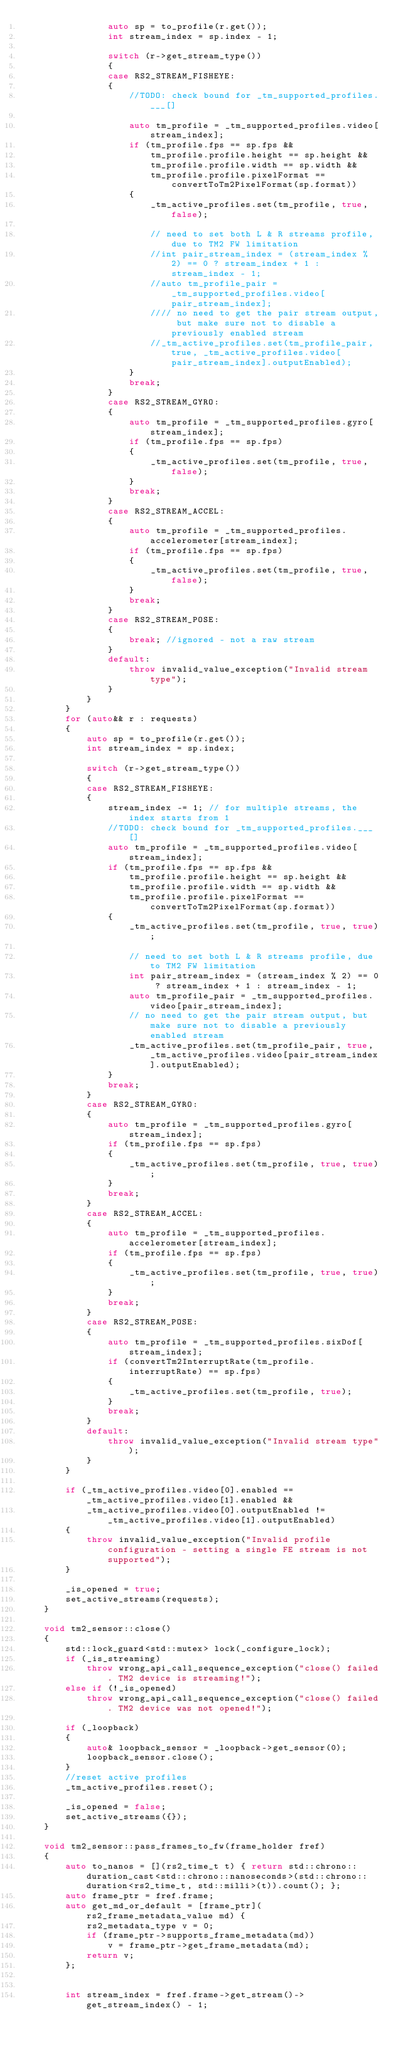<code> <loc_0><loc_0><loc_500><loc_500><_C++_>                auto sp = to_profile(r.get());
                int stream_index = sp.index - 1;

                switch (r->get_stream_type())
                {
                case RS2_STREAM_FISHEYE:
                {
                    //TODO: check bound for _tm_supported_profiles.___[]

                    auto tm_profile = _tm_supported_profiles.video[stream_index];
                    if (tm_profile.fps == sp.fps &&
                        tm_profile.profile.height == sp.height &&
                        tm_profile.profile.width == sp.width &&
                        tm_profile.profile.pixelFormat == convertToTm2PixelFormat(sp.format))
                    {
                        _tm_active_profiles.set(tm_profile, true, false);

                        // need to set both L & R streams profile, due to TM2 FW limitation
                        //int pair_stream_index = (stream_index % 2) == 0 ? stream_index + 1 : stream_index - 1;
                        //auto tm_profile_pair = _tm_supported_profiles.video[pair_stream_index];
                        //// no need to get the pair stream output, but make sure not to disable a previously enabled stream
                        //_tm_active_profiles.set(tm_profile_pair, true, _tm_active_profiles.video[pair_stream_index].outputEnabled);
                    }
                    break;
                }
                case RS2_STREAM_GYRO:
                {
                    auto tm_profile = _tm_supported_profiles.gyro[stream_index];
                    if (tm_profile.fps == sp.fps)
                    {
                        _tm_active_profiles.set(tm_profile, true, false);
                    }
                    break;
                }
                case RS2_STREAM_ACCEL:
                {
                    auto tm_profile = _tm_supported_profiles.accelerometer[stream_index];
                    if (tm_profile.fps == sp.fps)
                    {
                        _tm_active_profiles.set(tm_profile, true, false);
                    }
                    break;
                }
                case RS2_STREAM_POSE:
                {
                    break; //ignored - not a raw stream
                }
                default:
                    throw invalid_value_exception("Invalid stream type");
                }
            }
        }
        for (auto&& r : requests)
        {
            auto sp = to_profile(r.get());
            int stream_index = sp.index;
            
            switch (r->get_stream_type())
            {
            case RS2_STREAM_FISHEYE:
            {
                stream_index -= 1; // for multiple streams, the index starts from 1
                //TODO: check bound for _tm_supported_profiles.___[]
                auto tm_profile = _tm_supported_profiles.video[stream_index];
                if (tm_profile.fps == sp.fps &&
                    tm_profile.profile.height == sp.height &&
                    tm_profile.profile.width == sp.width &&
                    tm_profile.profile.pixelFormat == convertToTm2PixelFormat(sp.format))
                {
                    _tm_active_profiles.set(tm_profile, true, true);

                    // need to set both L & R streams profile, due to TM2 FW limitation
                    int pair_stream_index = (stream_index % 2) == 0 ? stream_index + 1 : stream_index - 1;
                    auto tm_profile_pair = _tm_supported_profiles.video[pair_stream_index];
                    // no need to get the pair stream output, but make sure not to disable a previously enabled stream
                    _tm_active_profiles.set(tm_profile_pair, true, _tm_active_profiles.video[pair_stream_index].outputEnabled);
                }
                break;
            }
            case RS2_STREAM_GYRO:
            {
                auto tm_profile = _tm_supported_profiles.gyro[stream_index];
                if (tm_profile.fps == sp.fps)
                {
                    _tm_active_profiles.set(tm_profile, true, true);
                }
                break;
            }
            case RS2_STREAM_ACCEL:
            {
                auto tm_profile = _tm_supported_profiles.accelerometer[stream_index];
                if (tm_profile.fps == sp.fps)
                {
                    _tm_active_profiles.set(tm_profile, true, true);
                }
                break;
            }
            case RS2_STREAM_POSE:
            {
                auto tm_profile = _tm_supported_profiles.sixDof[stream_index];
                if (convertTm2InterruptRate(tm_profile.interruptRate) == sp.fps)
                {
                    _tm_active_profiles.set(tm_profile, true);
                }
                break;
            }
            default:
                throw invalid_value_exception("Invalid stream type");
            }
        }

        if (_tm_active_profiles.video[0].enabled == _tm_active_profiles.video[1].enabled &&
            _tm_active_profiles.video[0].outputEnabled != _tm_active_profiles.video[1].outputEnabled)
        {
            throw invalid_value_exception("Invalid profile configuration - setting a single FE stream is not supported");
        }

        _is_opened = true;
        set_active_streams(requests);
    }

    void tm2_sensor::close()
    {
        std::lock_guard<std::mutex> lock(_configure_lock);
        if (_is_streaming)
            throw wrong_api_call_sequence_exception("close() failed. TM2 device is streaming!");
        else if (!_is_opened)
            throw wrong_api_call_sequence_exception("close() failed. TM2 device was not opened!");

        if (_loopback)
        {
            auto& loopback_sensor = _loopback->get_sensor(0);
            loopback_sensor.close();
        }
        //reset active profiles
        _tm_active_profiles.reset();

        _is_opened = false;
        set_active_streams({});
    }

    void tm2_sensor::pass_frames_to_fw(frame_holder fref)
    {
        auto to_nanos = [](rs2_time_t t) { return std::chrono::duration_cast<std::chrono::nanoseconds>(std::chrono::duration<rs2_time_t, std::milli>(t)).count(); };
        auto frame_ptr = fref.frame;
        auto get_md_or_default = [frame_ptr](rs2_frame_metadata_value md) {
            rs2_metadata_type v = 0;
            if (frame_ptr->supports_frame_metadata(md))
                v = frame_ptr->get_frame_metadata(md);
            return v;
        };


        int stream_index = fref.frame->get_stream()->get_stream_index() - 1;</code> 